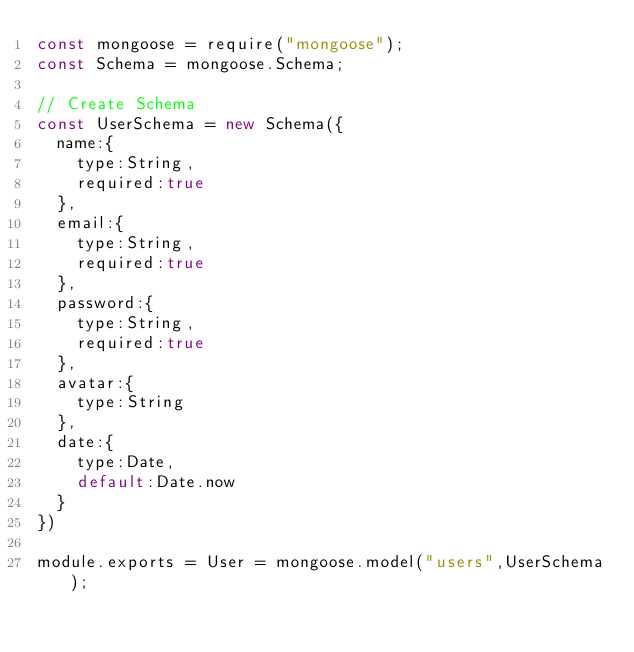<code> <loc_0><loc_0><loc_500><loc_500><_JavaScript_>const mongoose = require("mongoose");
const Schema = mongoose.Schema;

// Create Schema
const UserSchema = new Schema({
  name:{
    type:String,
    required:true
  },
  email:{
    type:String,
    required:true
  },
  password:{
    type:String,
    required:true
  },
  avatar:{
    type:String
  },
  date:{
    type:Date,
    default:Date.now
  }
})

module.exports = User = mongoose.model("users",UserSchema);</code> 